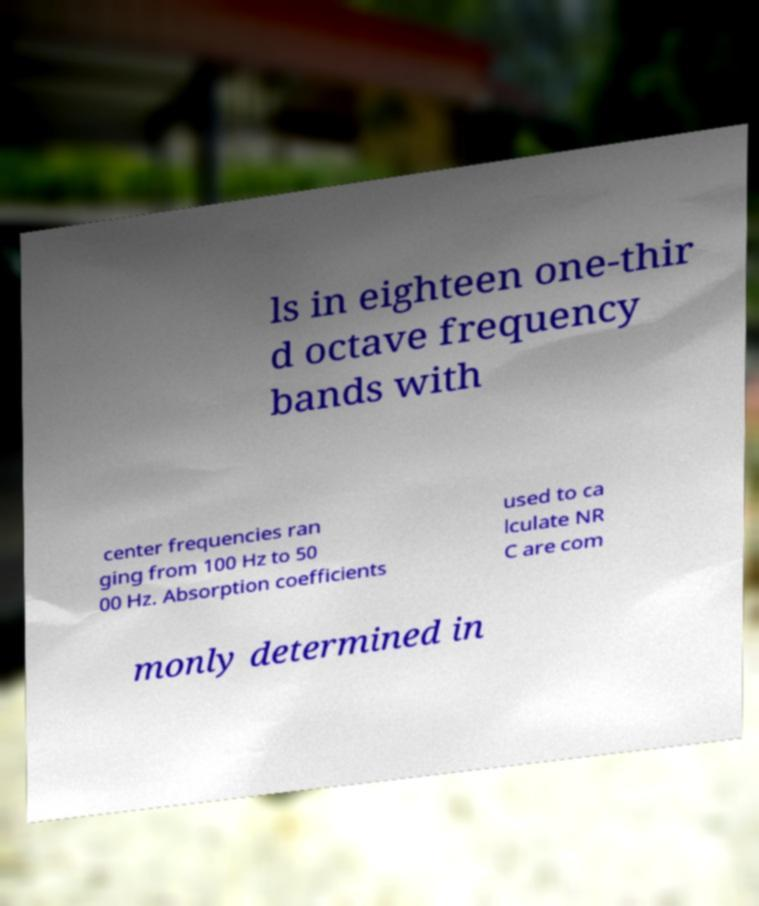Can you read and provide the text displayed in the image?This photo seems to have some interesting text. Can you extract and type it out for me? ls in eighteen one-thir d octave frequency bands with center frequencies ran ging from 100 Hz to 50 00 Hz. Absorption coefficients used to ca lculate NR C are com monly determined in 